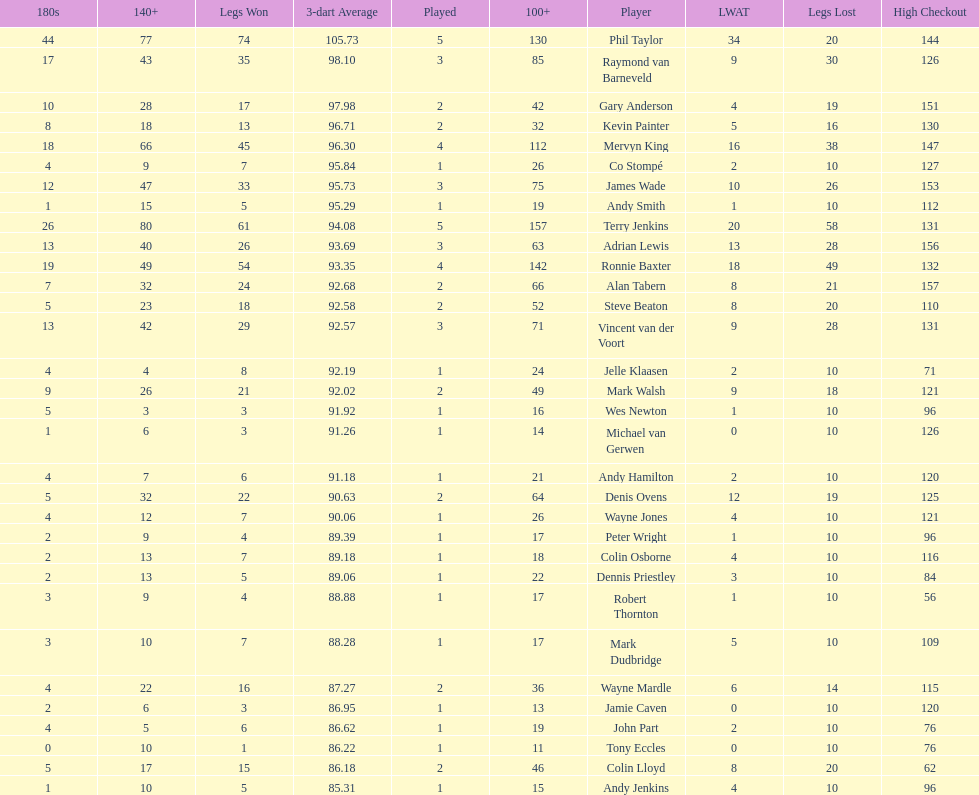What are the number of legs lost by james wade? 26. 